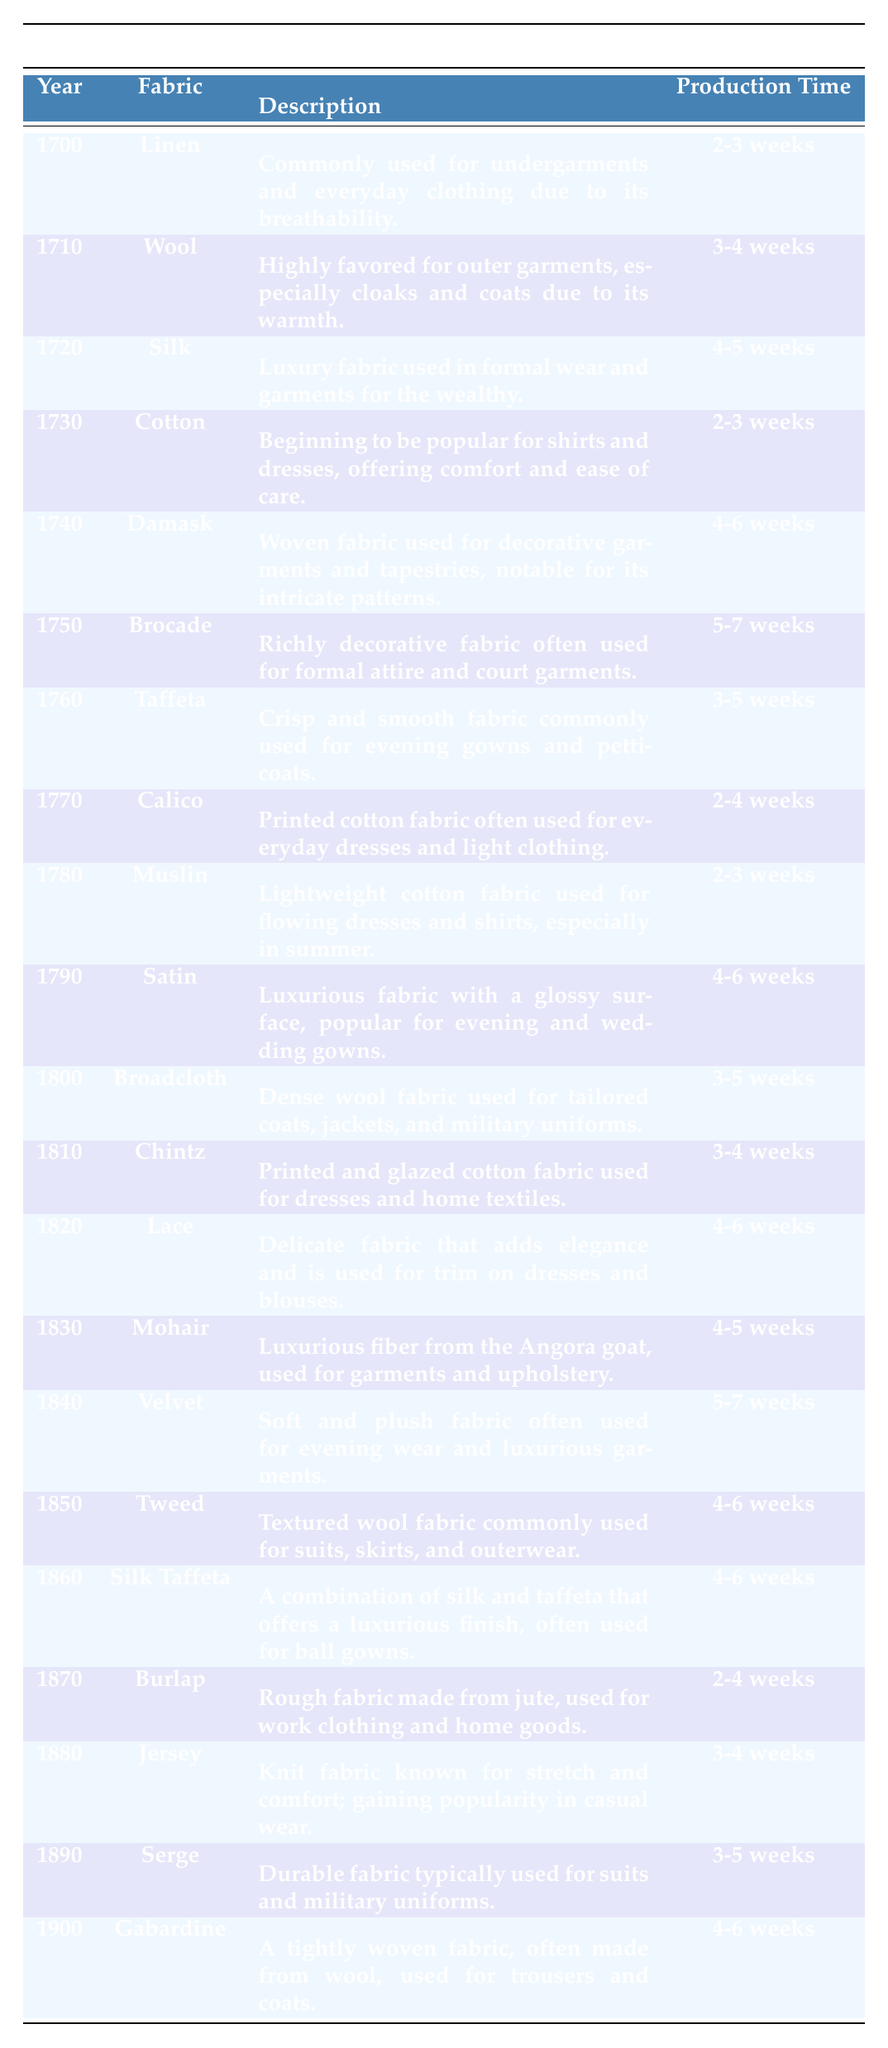What fabric was used in 1750, and what was its production time? The table shows that in 1750, the fabric used was "Brocade" and it had a production time of "5-7 weeks". Since this is a straightforward retrieval of information from the table, I simply looked for the row with the year 1750.
Answer: Brocade; 5-7 weeks Which fabric took the longest to produce according to the table? After reviewing the production times listed, the longest production time is "5-7 weeks," which is associated with both "Brocade" in 1750 and "Velvet" in 1840. Both fabrics have the highest production time range.
Answer: Brocade and Velvet Is "Silk" mentioned more than once in the table, and if so, what are the years it appears? A review of the table indicates that "Silk" appears once in the year 1720 and again in the combination of "Silk Taffeta" in 1860. Therefore, it does not appear multiple times as the same fabric.
Answer: No What fabric was used most often for outer garments between 1700 and 1900? In reviewing the table, "Wool" in 1710 and "Broadcloth" in 1800 are specifically noted for outer garments, indicating that both are frequently associated with this category. However, "Wool" is emphasized more for cloaks and coats, making it a primary choice for outerwear.
Answer: Wool Which fabrics have a production time of 2-3 weeks, and how many entries match that duration? The table shows three fabrics with a production time of "2-3 weeks": "Linen" in 1700, "Cotton" in 1730, and "Muslin" in 1780. Counting these entries, there are three fabrics.
Answer: Linen, Cotton, Muslin; 3 In what year did the use of "Calico" fabric become popular, and what was its purpose? The table indicates that "Calico" was used in 1770 for everyday dresses and light clothing. By checking the year and reading its description, we can confirm its purpose.
Answer: 1770; everyday dresses and light clothing What is the average production time for all fabrics used from 1800 to 1900? The production times for that range are: "3-5 weeks" for Broadcloth, "3-4 weeks" for Chintz, "4-6 weeks" for Lace, "4-5 weeks" for Mohair, "5-7 weeks" for Velvet, "4-6 weeks" for Tweed, "4-6 weeks" for Silk Taffeta, "2-4 weeks" for Burlap, "3-4 weeks" for Jersey, "3-5 weeks" for Serge, and "4-6 weeks" for Gabardine. Calculating the average requires converting time ranges into numbers, then finding the average of these numbers. After totaling both the minimum and maximum values and averaging them, the average production time is about 4 weeks.
Answer: 4 weeks Which fabric was used primarily for military uniforms during this time period? According to the table, "Broadcloth" in 1800 and "Serge" in 1890 are specified for military uniforms. Both matches are noted in the descriptions, confirming their use in that context.
Answer: Broadcloth and Serge 